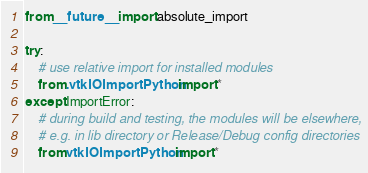<code> <loc_0><loc_0><loc_500><loc_500><_Python_>from __future__ import absolute_import

try:
    # use relative import for installed modules
    from .vtkIOImportPython import *
except ImportError:
    # during build and testing, the modules will be elsewhere,
    # e.g. in lib directory or Release/Debug config directories
    from vtkIOImportPython import *
</code> 